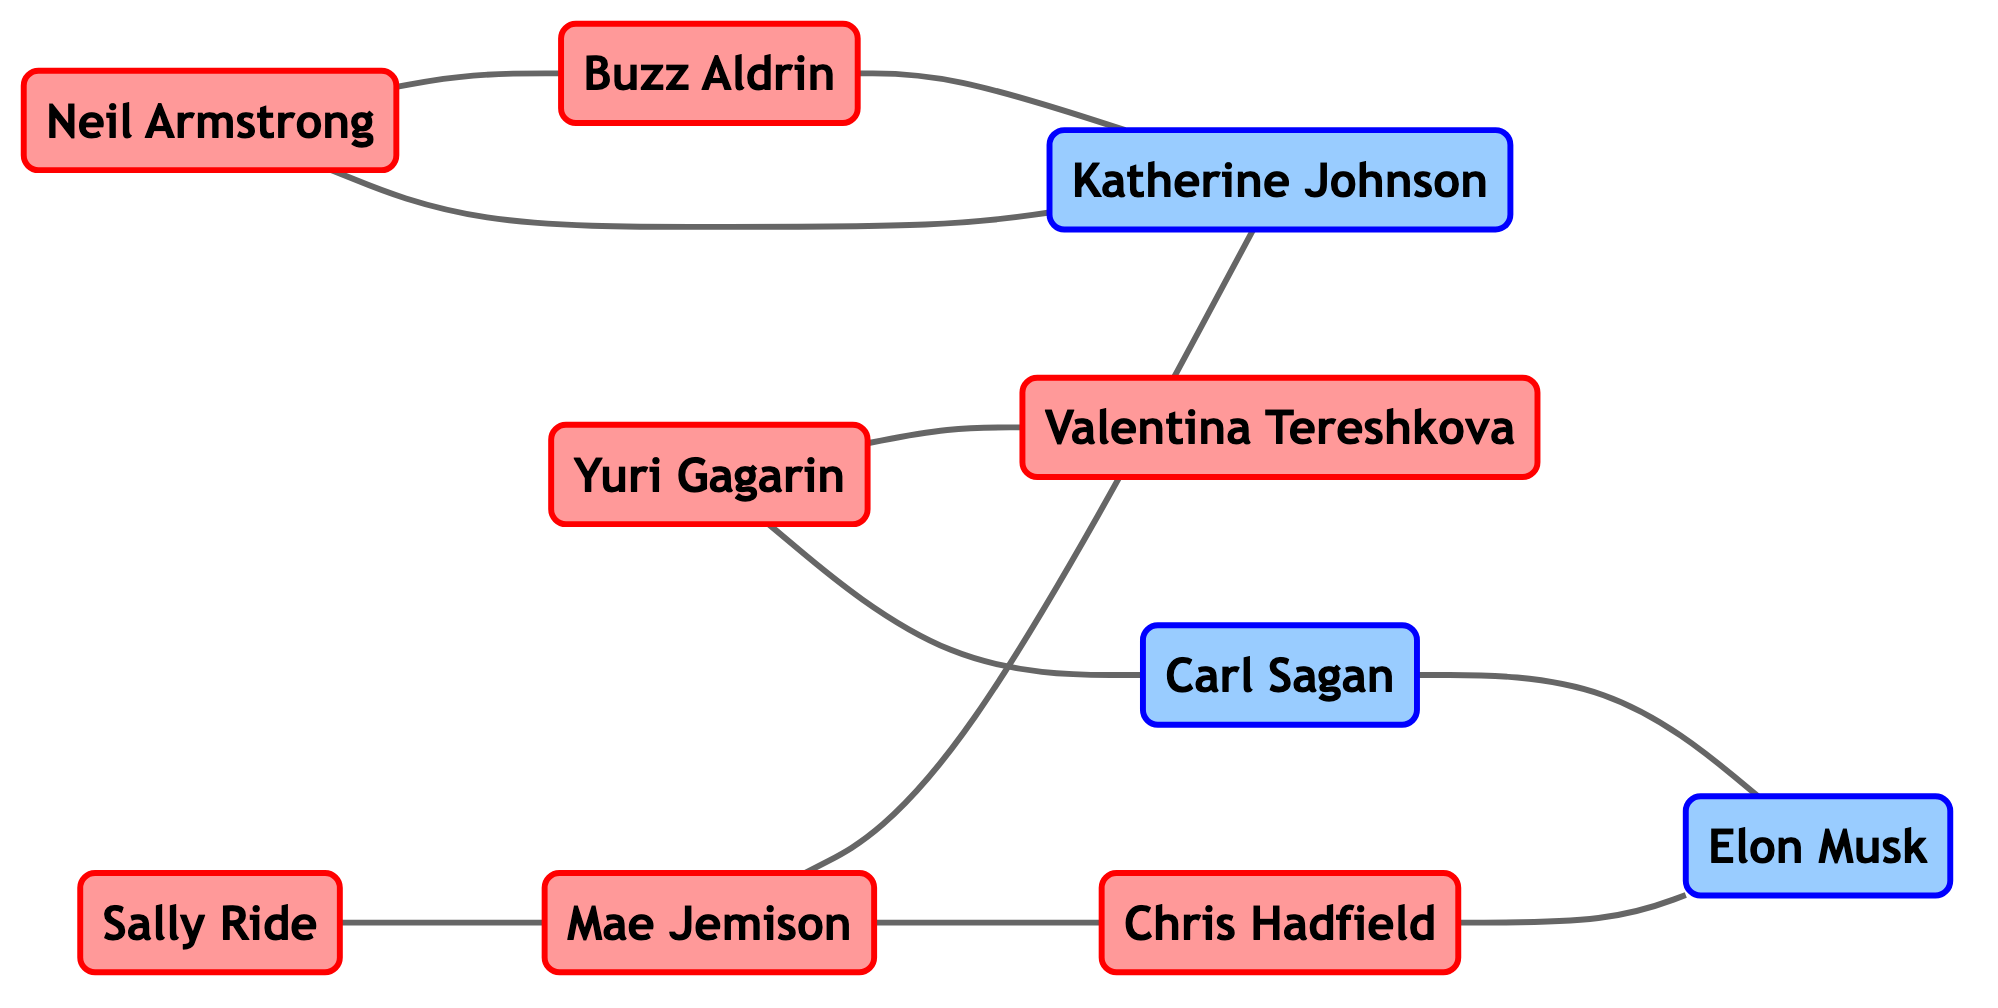What is the total number of astronauts in the diagram? The diagram shows a list of nodes, where the role "Astronaut" is specified. Counting all the nodes labeled as "Astronaut" gives us 6.
Answer: 6 How many edges are connected to Chris Hadfield? To find the edges connected to Chris Hadfield, we check the edges for connections. There are two edges: one connecting to Elon Musk and another connecting to Mae Jemison.
Answer: 2 Which astronaut has a direct working relationship with Mae Jemison? Mae Jemison has edges connecting to Sally Ride and Chris Hadfield. Checking the edges, it is evident that both have direct relationships with her.
Answer: Sally Ride, Chris Hadfield Who is the only astronaut connected to both Neil Armstrong and Katherine Johnson? Looking at the edges, Neil Armstrong connects to Katherine Johnson directly, and the only astronaut who has edges with both is Buzz Aldrin.
Answer: Buzz Aldrin Is there a direct link between Carl Sagan and any astronaut? Checking the edges, Carl Sagan is connected to Yuri Gagarin, who is an astronaut. Thus, he has a direct link to an astronaut.
Answer: Yes What role does Katherine Johnson play in this network? Katherine Johnson is classified as a scientist in the node descriptions, as indicated in the diagram’s legend.
Answer: Scientist Which astronaut has the highest number of connections in this graph? Analyzing the edges, Mae Jemison has 3 connections (to Sally Ride, Katherine Johnson, and Chris Hadfield), which is the highest among the astronauts.
Answer: Mae Jemison How many total relationships (edges) are present in the network? By counting all the edges in the network listing, we find a total of 10 edges between nodes.
Answer: 10 Which two astronauts are directly connected to Yuri Gagarin? The edges show that Yuri Gagarin is connected to Valentina Tereshkova and Carl Sagan directly.
Answer: Valentina Tereshkova, Carl Sagan 